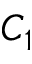Convert formula to latex. <formula><loc_0><loc_0><loc_500><loc_500>C _ { 1 }</formula> 